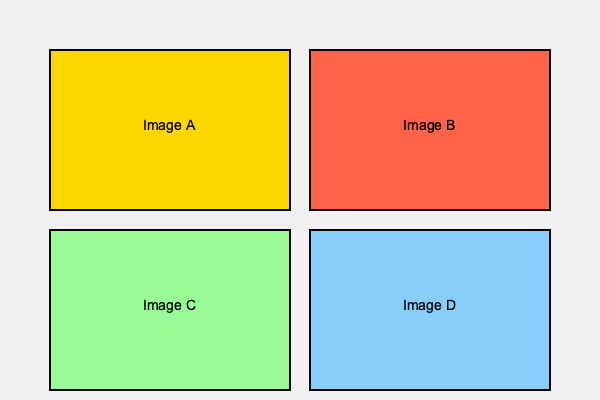Based on the histological features shown in the microscope images above, which of the four images (A, B, C, or D) most likely represents an adrenocortical carcinoma? To identify the image that most likely represents an adrenocortical carcinoma, we need to consider the typical histological features of this malignant tumor:

1. Image A (yellow): Shows a well-organized cellular structure with clear boundaries, suggesting a benign tumor or normal adrenal tissue.

2. Image B (red): Displays a disorganized cellular architecture with:
   a) Nuclear pleomorphism (variation in nuclear size and shape)
   b) High nuclear-to-cytoplasmic ratio
   c) Atypical mitotic figures
   d) Areas of necrosis
   These features are characteristic of adrenocortical carcinoma.

3. Image C (green): Exhibits a uniform cellular pattern with minimal nuclear atypia, indicative of a benign adrenal tumor such as an adenoma.

4. Image D (blue): Shows a cellular arrangement reminiscent of pheochromocytoma, with nests of cells (Zellballen pattern) but lacking the severe atypia seen in adrenocortical carcinoma.

Given these observations, Image B displays the most typical histological features of adrenocortical carcinoma, including cellular pleomorphism, nuclear atypia, and a disorganized growth pattern.
Answer: B 